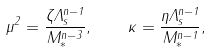<formula> <loc_0><loc_0><loc_500><loc_500>\mu ^ { 2 } = \frac { \zeta \Lambda _ { s } ^ { n - 1 } } { M _ { * } ^ { n - 3 } } , \quad \kappa = \frac { \eta \Lambda _ { s } ^ { n - 1 } } { M _ { * } ^ { n - 1 } } ,</formula> 